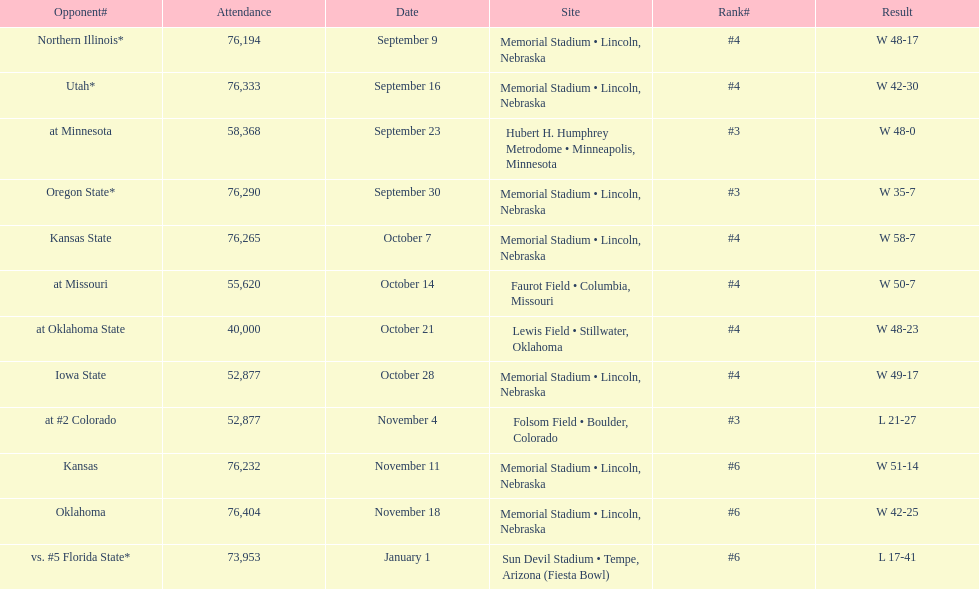What site at most is taken place? Memorial Stadium • Lincoln, Nebraska. 